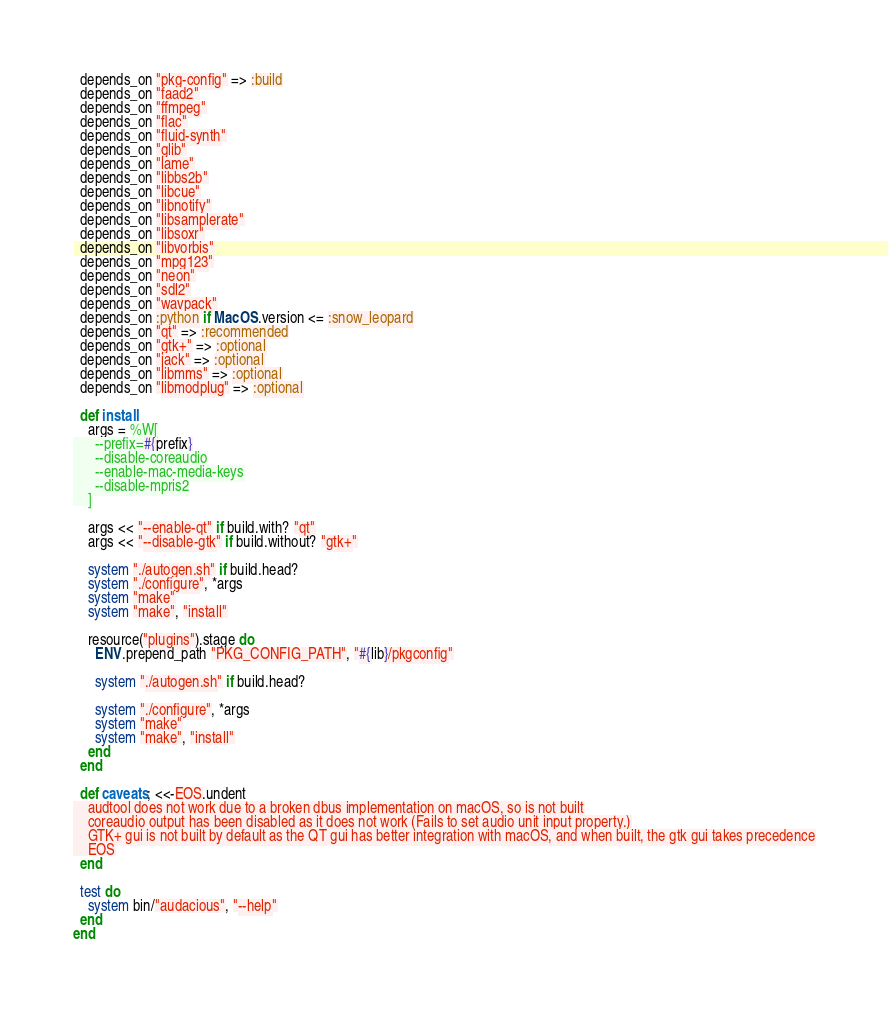<code> <loc_0><loc_0><loc_500><loc_500><_Ruby_>  depends_on "pkg-config" => :build
  depends_on "faad2"
  depends_on "ffmpeg"
  depends_on "flac"
  depends_on "fluid-synth"
  depends_on "glib"
  depends_on "lame"
  depends_on "libbs2b"
  depends_on "libcue"
  depends_on "libnotify"
  depends_on "libsamplerate"
  depends_on "libsoxr"
  depends_on "libvorbis"
  depends_on "mpg123"
  depends_on "neon"
  depends_on "sdl2"
  depends_on "wavpack"
  depends_on :python if MacOS.version <= :snow_leopard
  depends_on "qt" => :recommended
  depends_on "gtk+" => :optional
  depends_on "jack" => :optional
  depends_on "libmms" => :optional
  depends_on "libmodplug" => :optional

  def install
    args = %W[
      --prefix=#{prefix}
      --disable-coreaudio
      --enable-mac-media-keys
      --disable-mpris2
    ]

    args << "--enable-qt" if build.with? "qt"
    args << "--disable-gtk" if build.without? "gtk+"

    system "./autogen.sh" if build.head?
    system "./configure", *args
    system "make"
    system "make", "install"

    resource("plugins").stage do
      ENV.prepend_path "PKG_CONFIG_PATH", "#{lib}/pkgconfig"

      system "./autogen.sh" if build.head?

      system "./configure", *args
      system "make"
      system "make", "install"
    end
  end

  def caveats; <<-EOS.undent
    audtool does not work due to a broken dbus implementation on macOS, so is not built
    coreaudio output has been disabled as it does not work (Fails to set audio unit input property.)
    GTK+ gui is not built by default as the QT gui has better integration with macOS, and when built, the gtk gui takes precedence
    EOS
  end

  test do
    system bin/"audacious", "--help"
  end
end
</code> 